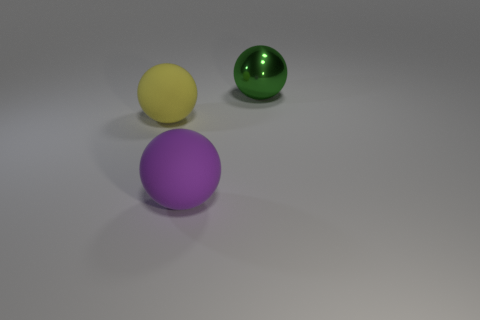What is the size of the shiny thing? The shiny object in the image is a green sphere that appears medium-sized compared to the other objects in the scene. It reflects light, indicating a smooth and possibly polished surface. 